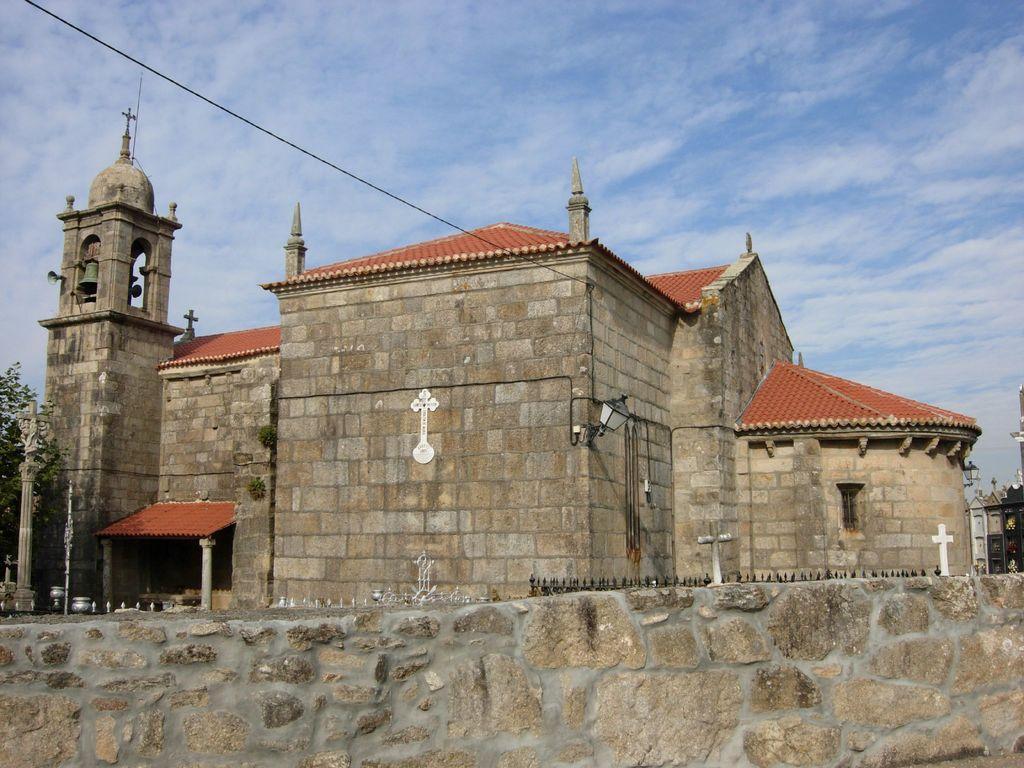How would you summarize this image in a sentence or two? There is a stone wall. There is a building which has roof and stone wall. There is a lamp and a tree at the left. There is a wire and sky at the top. 